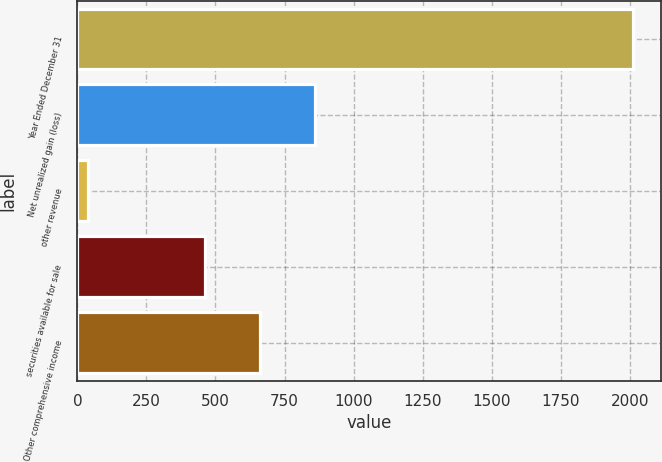Convert chart to OTSL. <chart><loc_0><loc_0><loc_500><loc_500><bar_chart><fcel>Year Ended December 31<fcel>Net unrealized gain (loss)<fcel>other revenue<fcel>securities available for sale<fcel>Other comprehensive income<nl><fcel>2012<fcel>858.8<fcel>38<fcel>464<fcel>661.4<nl></chart> 